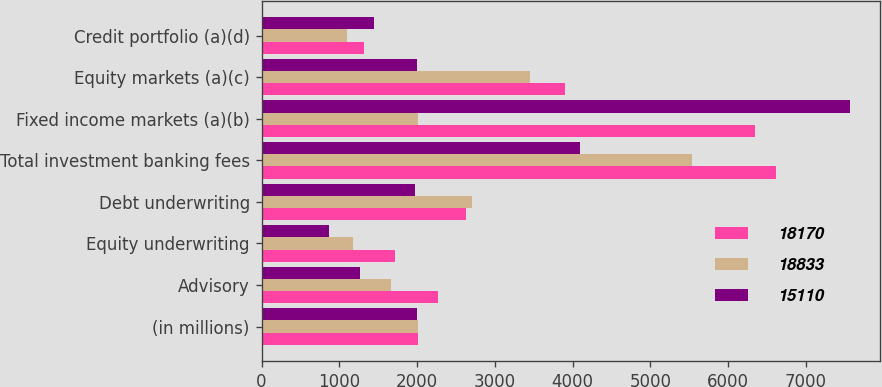Convert chart to OTSL. <chart><loc_0><loc_0><loc_500><loc_500><stacked_bar_chart><ecel><fcel>(in millions)<fcel>Advisory<fcel>Equity underwriting<fcel>Debt underwriting<fcel>Total investment banking fees<fcel>Fixed income markets (a)(b)<fcel>Equity markets (a)(c)<fcel>Credit portfolio (a)(d)<nl><fcel>18170<fcel>2007<fcel>2273<fcel>1713<fcel>2630<fcel>6616<fcel>6339<fcel>3903<fcel>1312<nl><fcel>18833<fcel>2006<fcel>1659<fcel>1178<fcel>2700<fcel>5537<fcel>2006<fcel>3458<fcel>1102<nl><fcel>15110<fcel>2005<fcel>1263<fcel>864<fcel>1969<fcel>4096<fcel>7570<fcel>1998<fcel>1446<nl></chart> 